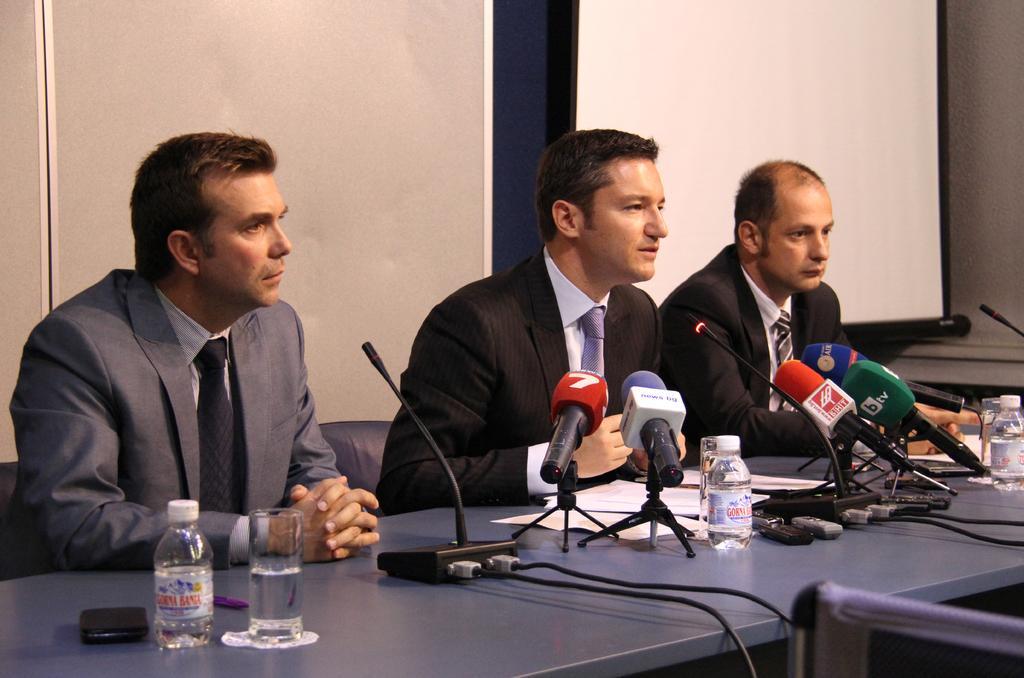In one or two sentences, can you explain what this image depicts? There are men those who are sitting in the center of the image and there is a table in front of them, on which there are mice, papers, water bottles, and glasses are there, it seems to be there are screens in the background area of the image. 